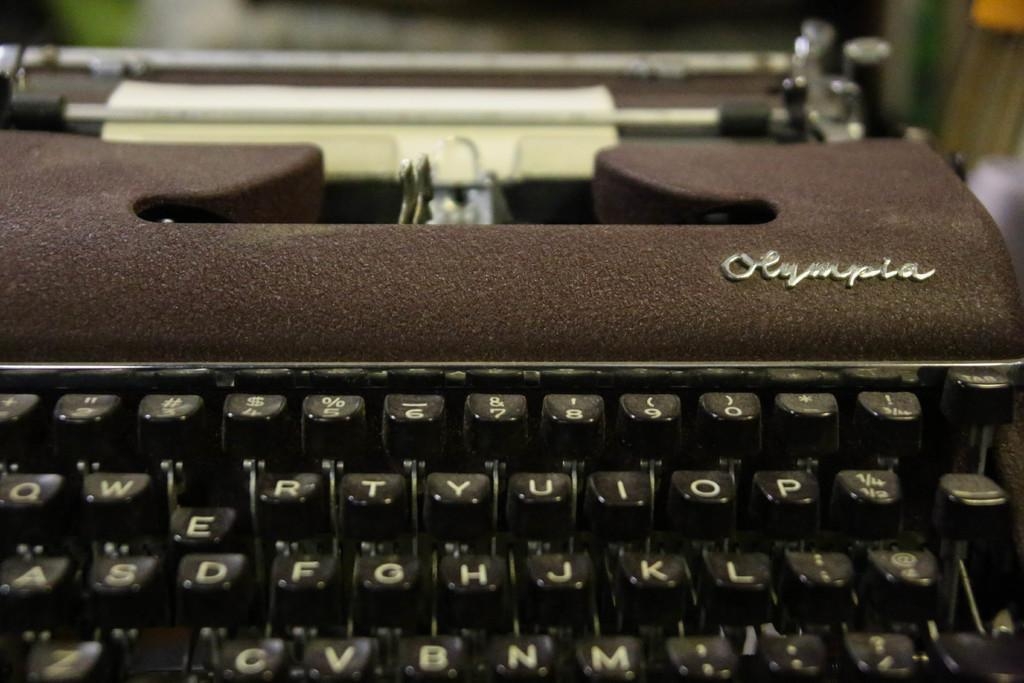<image>
Share a concise interpretation of the image provided. A manual typewriter with a unique finish was made by the Olympia company. 